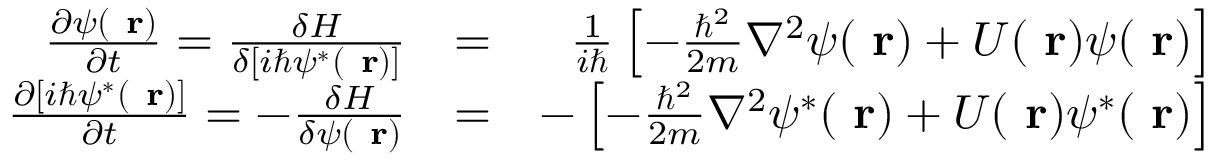<formula> <loc_0><loc_0><loc_500><loc_500>\begin{array} { r l r } { \frac { \partial \psi ( r ) } { \partial t } = \frac { \delta H } { \delta [ i \hbar { \psi } ^ { * } ( r ) ] } } & { = } & { \frac { 1 } { i } \left [ - \frac { \hbar { ^ } { 2 } } { 2 m } \nabla ^ { 2 } \psi ( r ) + U ( r ) \psi ( r ) \right ] } \\ { \frac { \partial [ i \hbar { \psi } ^ { * } ( r ) ] } { \partial t } = - \frac { \delta H } { \delta \psi ( r ) } } & { = } & { - \left [ - \frac { \hbar { ^ } { 2 } } { 2 m } \nabla ^ { 2 } \psi ^ { * } ( r ) + U ( r ) \psi ^ { * } ( r ) \right ] } \end{array}</formula> 